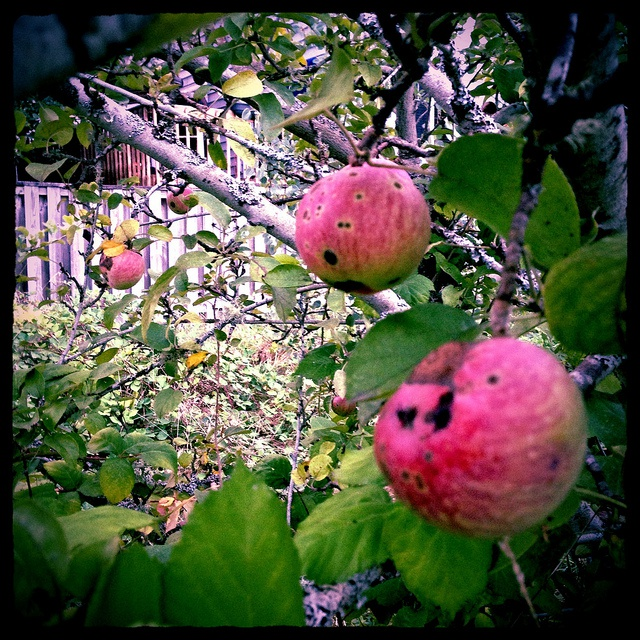Describe the objects in this image and their specific colors. I can see apple in black, violet, brown, and maroon tones, apple in black, violet, brown, and lightpink tones, apple in black, brown, violet, and maroon tones, and apple in black, maroon, and brown tones in this image. 